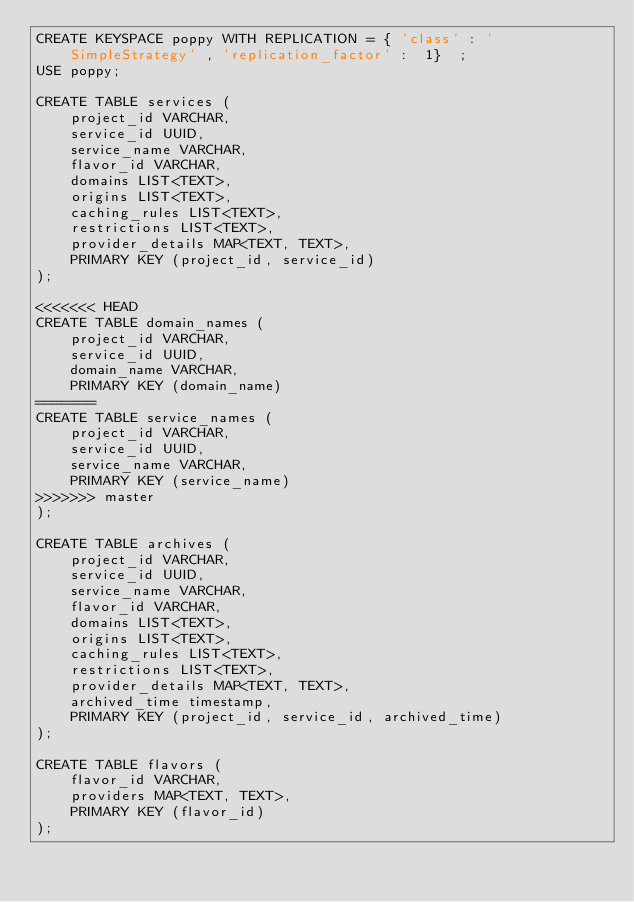<code> <loc_0><loc_0><loc_500><loc_500><_SQL_>CREATE KEYSPACE poppy WITH REPLICATION = { 'class' : 'SimpleStrategy' , 'replication_factor' :  1}  ;
USE poppy;

CREATE TABLE services (
    project_id VARCHAR,
    service_id UUID,
    service_name VARCHAR,
    flavor_id VARCHAR,
    domains LIST<TEXT>,
    origins LIST<TEXT>,
    caching_rules LIST<TEXT>,
    restrictions LIST<TEXT>,
    provider_details MAP<TEXT, TEXT>,
    PRIMARY KEY (project_id, service_id)
); 

<<<<<<< HEAD
CREATE TABLE domain_names (
    project_id VARCHAR,
    service_id UUID,
    domain_name VARCHAR,
    PRIMARY KEY (domain_name)
=======
CREATE TABLE service_names (
    project_id VARCHAR,
    service_id UUID,
    service_name VARCHAR,
    PRIMARY KEY (service_name)
>>>>>>> master
);

CREATE TABLE archives (
    project_id VARCHAR,
    service_id UUID,
    service_name VARCHAR,
    flavor_id VARCHAR,
    domains LIST<TEXT>,
    origins LIST<TEXT>,
    caching_rules LIST<TEXT>,
    restrictions LIST<TEXT>,
    provider_details MAP<TEXT, TEXT>,
    archived_time timestamp,
    PRIMARY KEY (project_id, service_id, archived_time)
);

CREATE TABLE flavors (
    flavor_id VARCHAR,
    providers MAP<TEXT, TEXT>,
    PRIMARY KEY (flavor_id)
);
</code> 